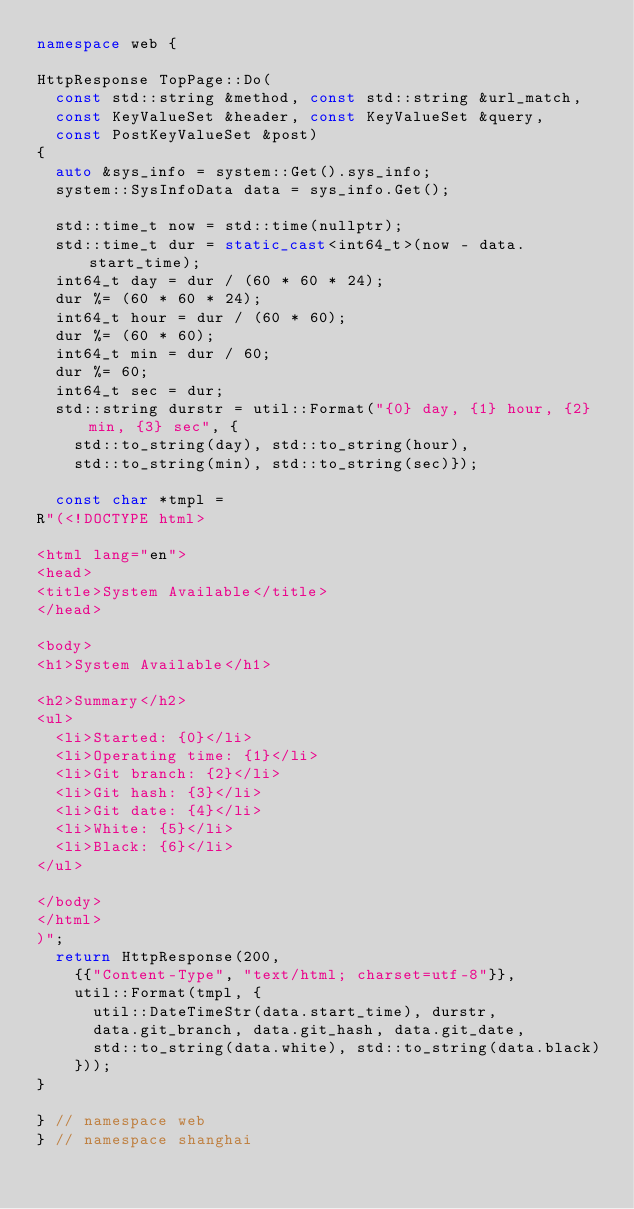<code> <loc_0><loc_0><loc_500><loc_500><_C++_>namespace web {

HttpResponse TopPage::Do(
	const std::string &method, const std::string &url_match,
	const KeyValueSet &header, const KeyValueSet &query,
	const PostKeyValueSet &post)
{
	auto &sys_info = system::Get().sys_info;
	system::SysInfoData data = sys_info.Get();

	std::time_t now = std::time(nullptr);
	std::time_t dur = static_cast<int64_t>(now - data.start_time);
	int64_t day = dur / (60 * 60 * 24);
	dur %= (60 * 60 * 24);
	int64_t hour = dur / (60 * 60);
	dur %= (60 * 60);
	int64_t min = dur / 60;
	dur %= 60;
	int64_t sec = dur;
	std::string durstr = util::Format("{0} day, {1} hour, {2} min, {3} sec", {
		std::to_string(day), std::to_string(hour),
		std::to_string(min), std::to_string(sec)});

	const char *tmpl =
R"(<!DOCTYPE html>

<html lang="en">
<head>
<title>System Available</title>
</head>

<body>
<h1>System Available</h1>

<h2>Summary</h2>
<ul>
  <li>Started: {0}</li>
  <li>Operating time: {1}</li>
  <li>Git branch: {2}</li>
  <li>Git hash: {3}</li>
  <li>Git date: {4}</li>
  <li>White: {5}</li>
  <li>Black: {6}</li>
</ul>

</body>
</html>
)";
	return HttpResponse(200,
		{{"Content-Type", "text/html; charset=utf-8"}},
		util::Format(tmpl, {
			util::DateTimeStr(data.start_time), durstr,
			data.git_branch, data.git_hash, data.git_date,
			std::to_string(data.white), std::to_string(data.black)
		}));
}

}	// namespace web
}	// namespace shanghai
</code> 